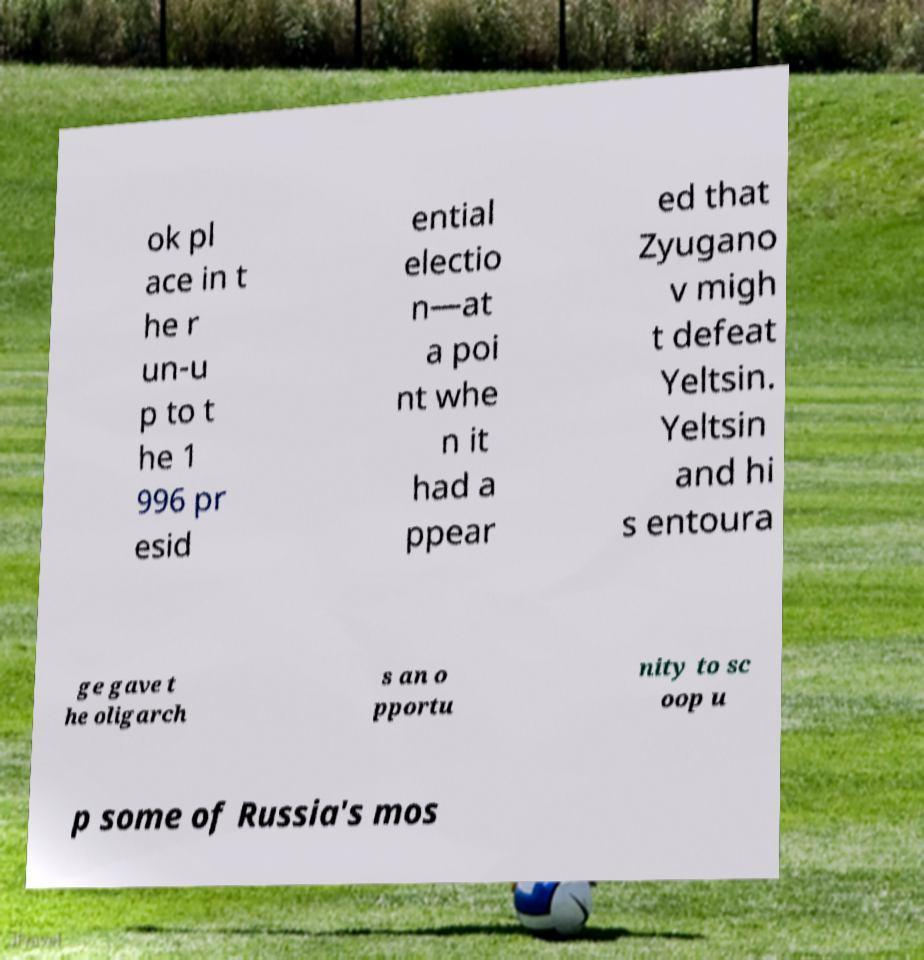Please read and relay the text visible in this image. What does it say? ok pl ace in t he r un-u p to t he 1 996 pr esid ential electio n—at a poi nt whe n it had a ppear ed that Zyugano v migh t defeat Yeltsin. Yeltsin and hi s entoura ge gave t he oligarch s an o pportu nity to sc oop u p some of Russia's mos 